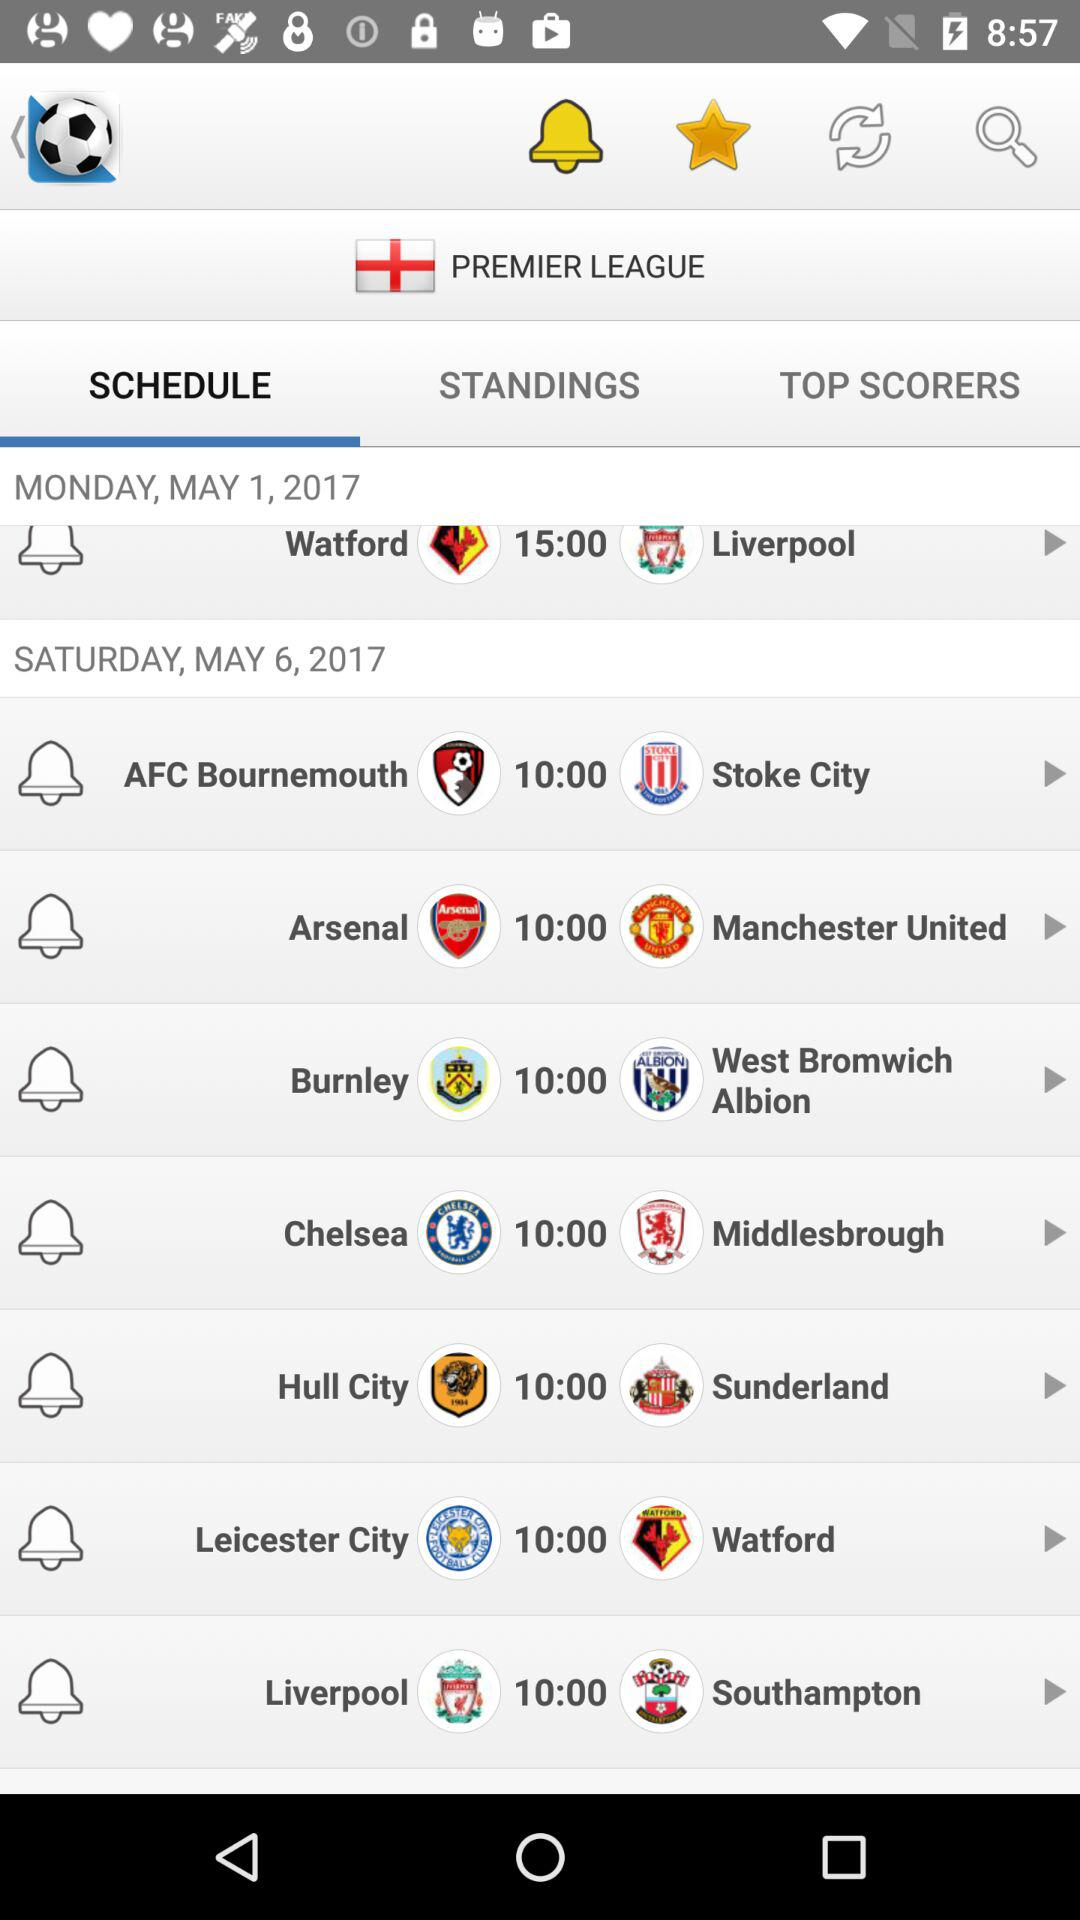What is the schedule for Monday, May 1, 2017? On Monday, May 1, 2017, there is a scheduled match between "Watford" and "Liverpool" at 15:00. 